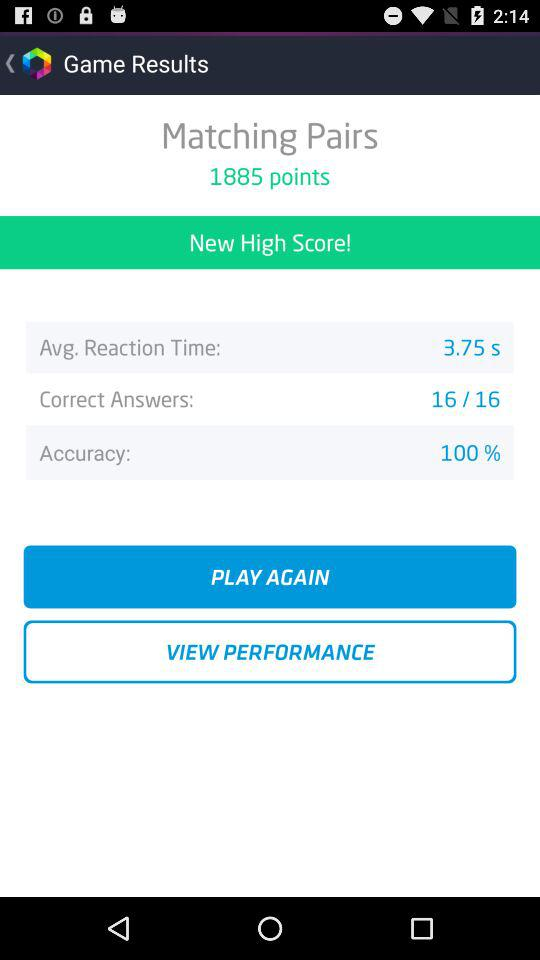How many more correct answers did I have than incorrect answers?
Answer the question using a single word or phrase. 16 